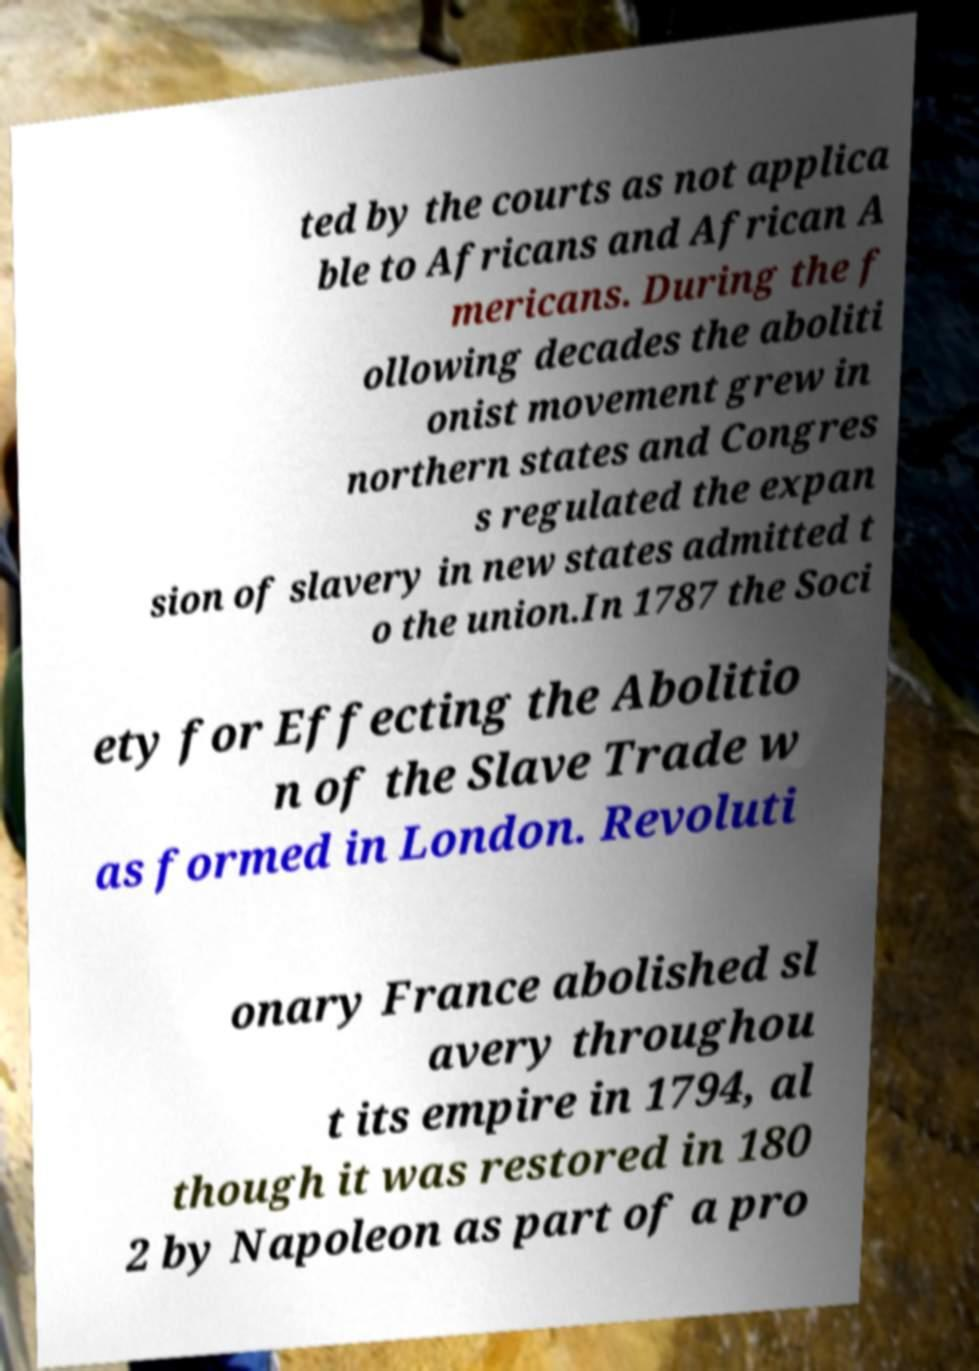Could you extract and type out the text from this image? ted by the courts as not applica ble to Africans and African A mericans. During the f ollowing decades the aboliti onist movement grew in northern states and Congres s regulated the expan sion of slavery in new states admitted t o the union.In 1787 the Soci ety for Effecting the Abolitio n of the Slave Trade w as formed in London. Revoluti onary France abolished sl avery throughou t its empire in 1794, al though it was restored in 180 2 by Napoleon as part of a pro 